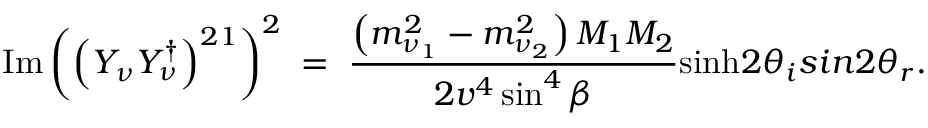Convert formula to latex. <formula><loc_0><loc_0><loc_500><loc_500>I m \left ( \left ( Y _ { \nu } Y _ { \nu } ^ { \dagger } \right ) ^ { 2 1 } \right ) ^ { 2 } \, = \, { \frac { \left ( m _ { \nu _ { 1 } } ^ { 2 } - m _ { \nu _ { 2 } } ^ { 2 } \right ) M _ { 1 } M _ { 2 } } { 2 v ^ { 4 } \sin ^ { 4 } \beta } } \sinh 2 \theta _ { i } \sin 2 \theta _ { r } .</formula> 